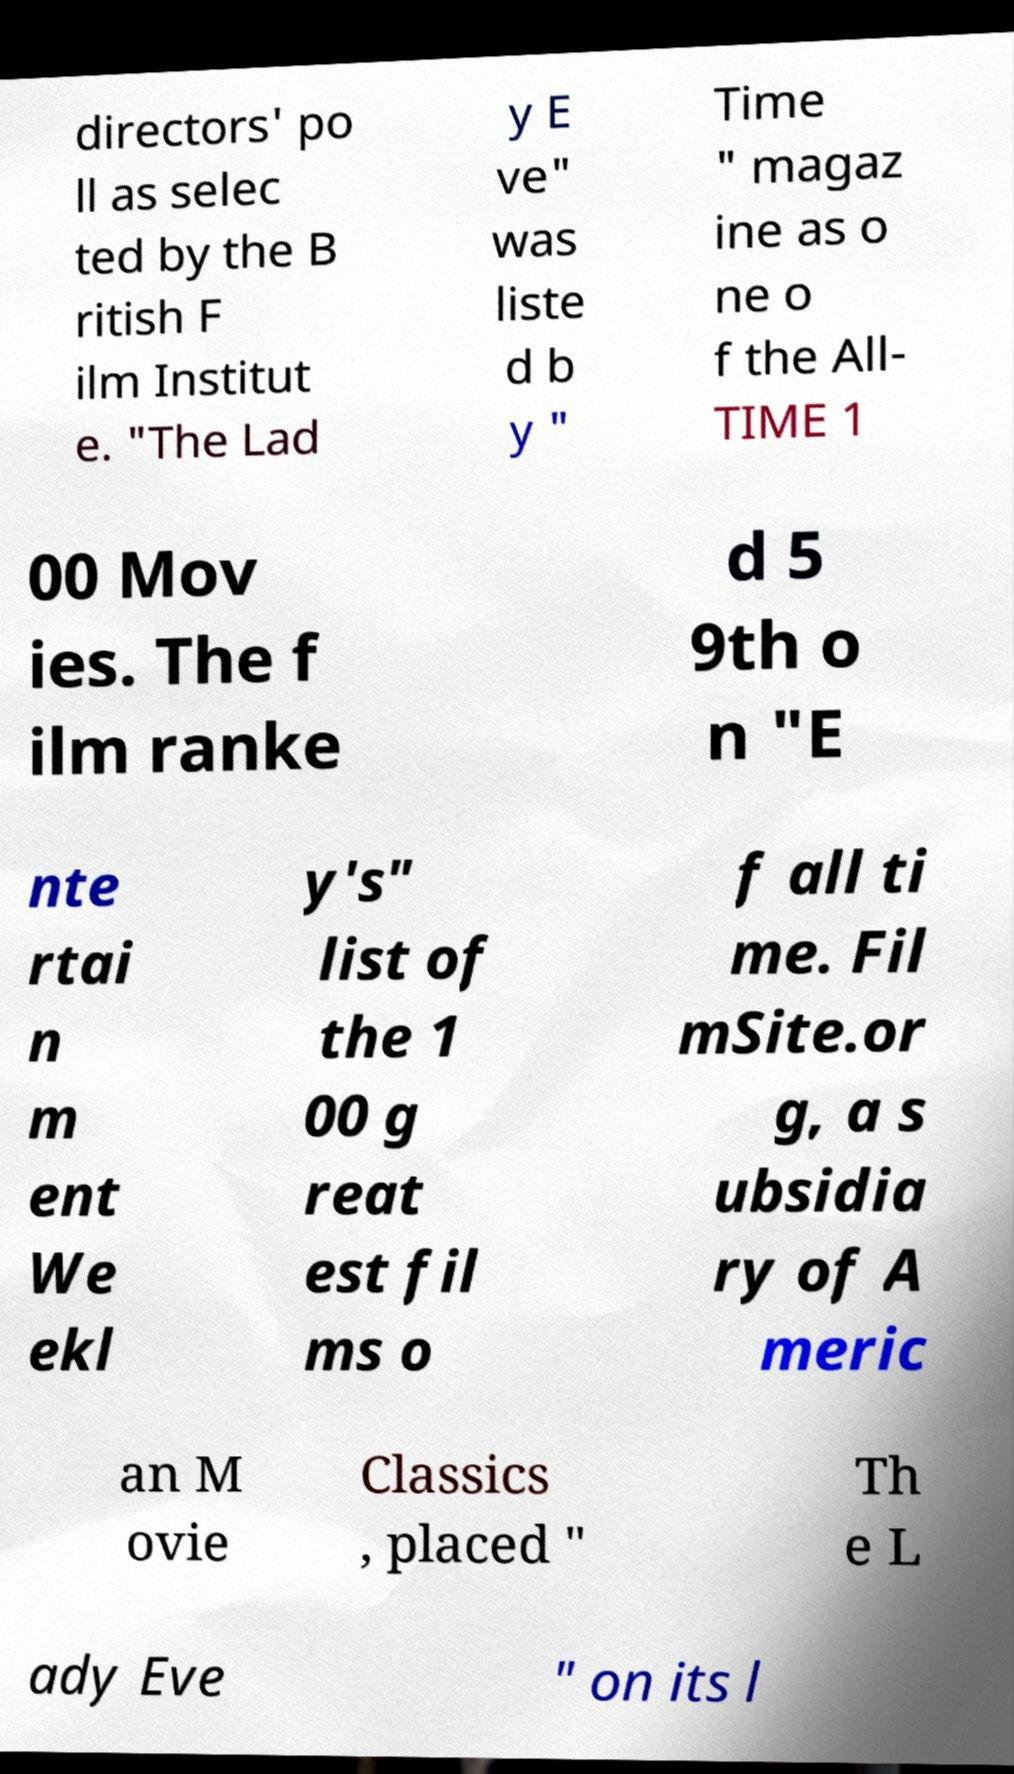Can you read and provide the text displayed in the image?This photo seems to have some interesting text. Can you extract and type it out for me? directors' po ll as selec ted by the B ritish F ilm Institut e. "The Lad y E ve" was liste d b y " Time " magaz ine as o ne o f the All- TIME 1 00 Mov ies. The f ilm ranke d 5 9th o n "E nte rtai n m ent We ekl y's" list of the 1 00 g reat est fil ms o f all ti me. Fil mSite.or g, a s ubsidia ry of A meric an M ovie Classics , placed " Th e L ady Eve " on its l 